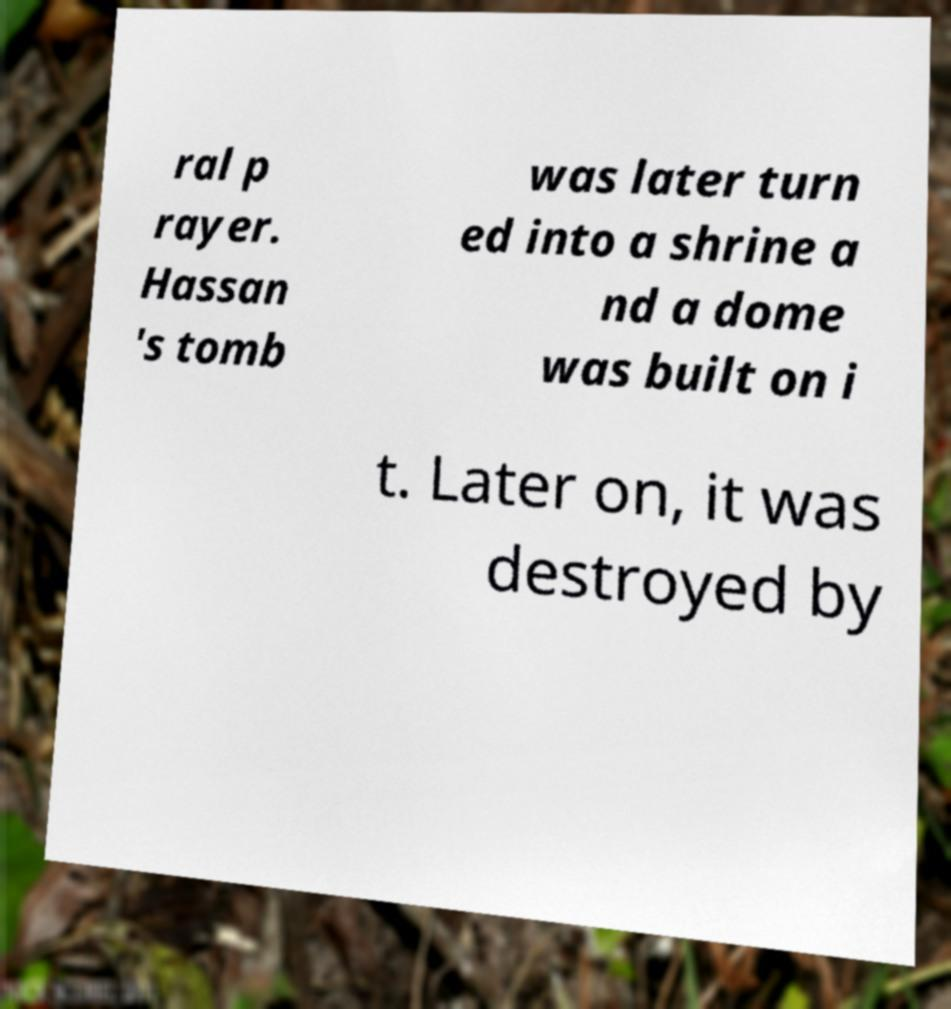For documentation purposes, I need the text within this image transcribed. Could you provide that? ral p rayer. Hassan 's tomb was later turn ed into a shrine a nd a dome was built on i t. Later on, it was destroyed by 